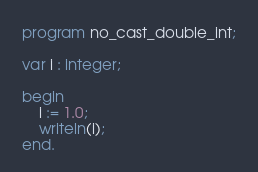<code> <loc_0><loc_0><loc_500><loc_500><_Pascal_>program no_cast_double_int;

var i : integer;

begin
    i := 1.0;
    writeln(i);
end.</code> 